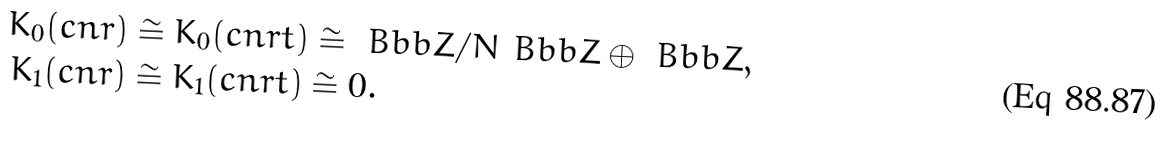<formula> <loc_0><loc_0><loc_500><loc_500>K _ { 0 } ( c n r ) & \cong K _ { 0 } ( c n r t ) \cong { \ B b b Z } / N { \ B b b Z } \oplus { \ B b b Z } , \\ K _ { 1 } ( c n r ) & \cong K _ { 1 } ( c n r t ) \cong 0 .</formula> 